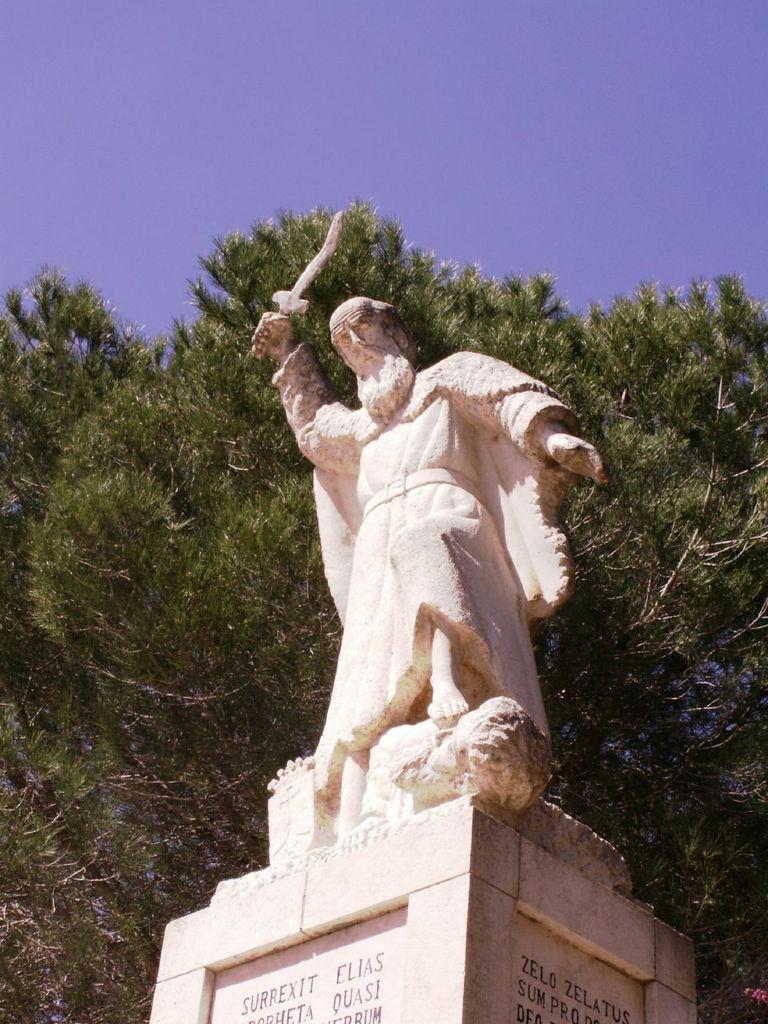In one or two sentences, can you explain what this image depicts? Here I can see a statue of a person is holding a sword in the hand. This statue is placed on a pillar on which I can see some text. In the background there is a tree. On the top of the image I can see the sky. 